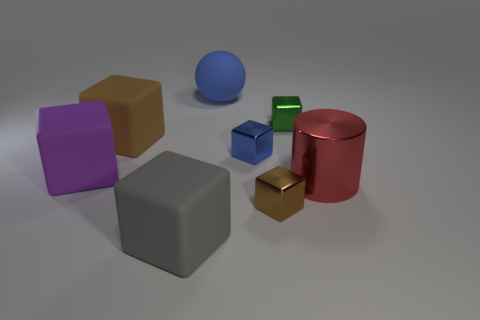How many other objects are there of the same shape as the small brown metallic object?
Offer a terse response. 5. Are there any big things behind the large purple matte thing?
Your response must be concise. Yes. What is the color of the metal cylinder?
Your answer should be compact. Red. Is the color of the large rubber sphere the same as the shiny block that is behind the small blue object?
Offer a terse response. No. Are there any metal cylinders that have the same size as the blue block?
Provide a short and direct response. No. What size is the cube that is the same color as the matte ball?
Keep it short and to the point. Small. What is the material of the brown cube that is behind the red metallic thing?
Your answer should be very brief. Rubber. Are there the same number of big gray things that are on the left side of the large purple thing and red metal cylinders that are behind the tiny green cube?
Make the answer very short. Yes. Does the gray matte object that is in front of the big blue matte object have the same size as the brown object to the right of the large blue matte thing?
Offer a terse response. No. What number of metal things are the same color as the big cylinder?
Your answer should be very brief. 0. 